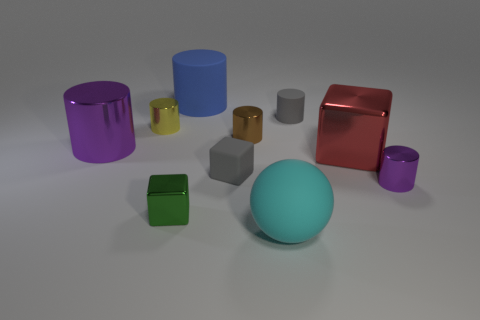What material is the gray thing that is the same shape as the brown metallic object?
Your response must be concise. Rubber. What material is the big object in front of the small shiny object to the right of the big metal cube made of?
Your answer should be compact. Rubber. Does the cyan object have the same shape as the large thing that is on the left side of the big rubber cylinder?
Offer a terse response. No. How many matte objects are either brown cylinders or purple cylinders?
Provide a short and direct response. 0. There is a tiny cylinder that is in front of the red block that is on the left side of the purple shiny cylinder right of the blue object; what color is it?
Provide a succinct answer. Purple. What number of other objects are the same material as the tiny gray cube?
Make the answer very short. 3. There is a big shiny thing that is on the right side of the blue thing; is its shape the same as the small green metallic object?
Make the answer very short. Yes. How many large things are either rubber cubes or blue shiny blocks?
Keep it short and to the point. 0. Are there the same number of large purple shiny cylinders that are behind the brown cylinder and large spheres behind the small gray rubber cylinder?
Ensure brevity in your answer.  Yes. How many other objects are the same color as the small metal cube?
Keep it short and to the point. 0. 